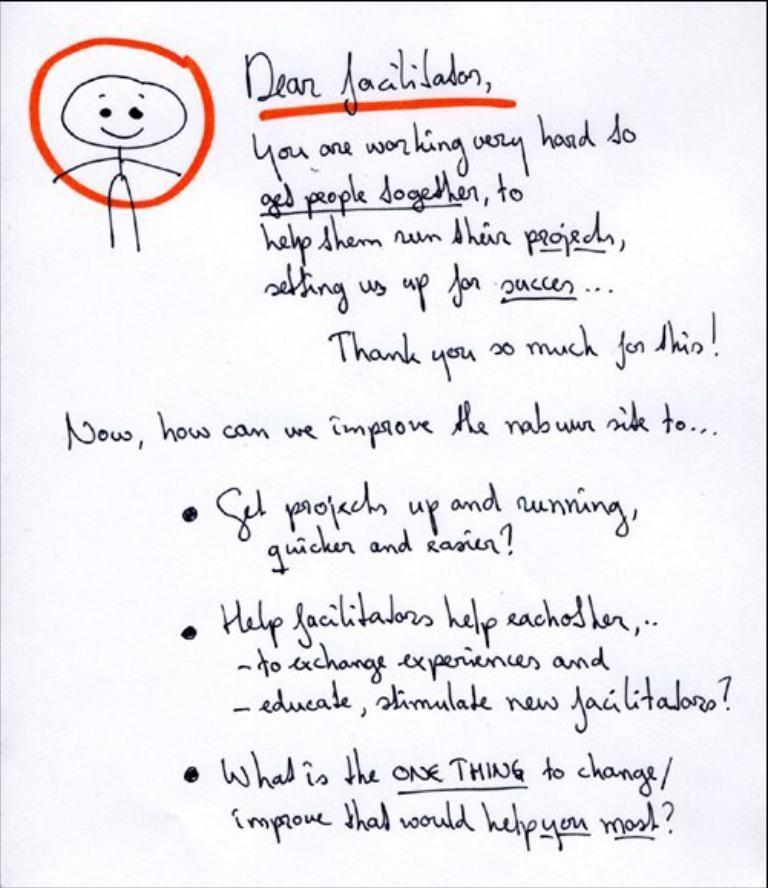Please provide a concise description of this image. In the image we can see there is a letter and there is a drawing of a person on it. The drawing of a person is circled with red colour ink and the matter in the letter is written with black colour ink. 